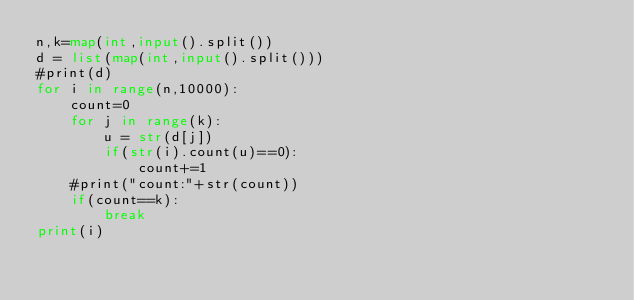Convert code to text. <code><loc_0><loc_0><loc_500><loc_500><_Python_>n,k=map(int,input().split())
d = list(map(int,input().split()))
#print(d)
for i in range(n,10000):
    count=0
    for j in range(k):
        u = str(d[j])
        if(str(i).count(u)==0):
            count+=1
    #print("count:"+str(count))
    if(count==k):
        break
print(i)</code> 